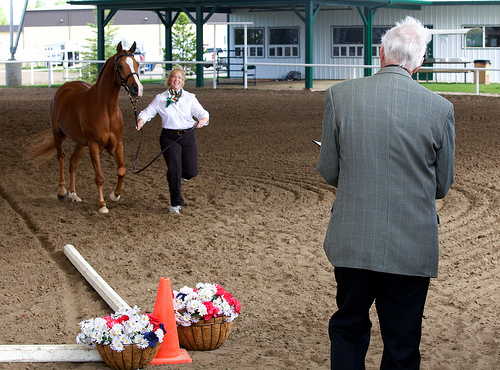<image>
Can you confirm if the horse is in front of the woman? No. The horse is not in front of the woman. The spatial positioning shows a different relationship between these objects. 